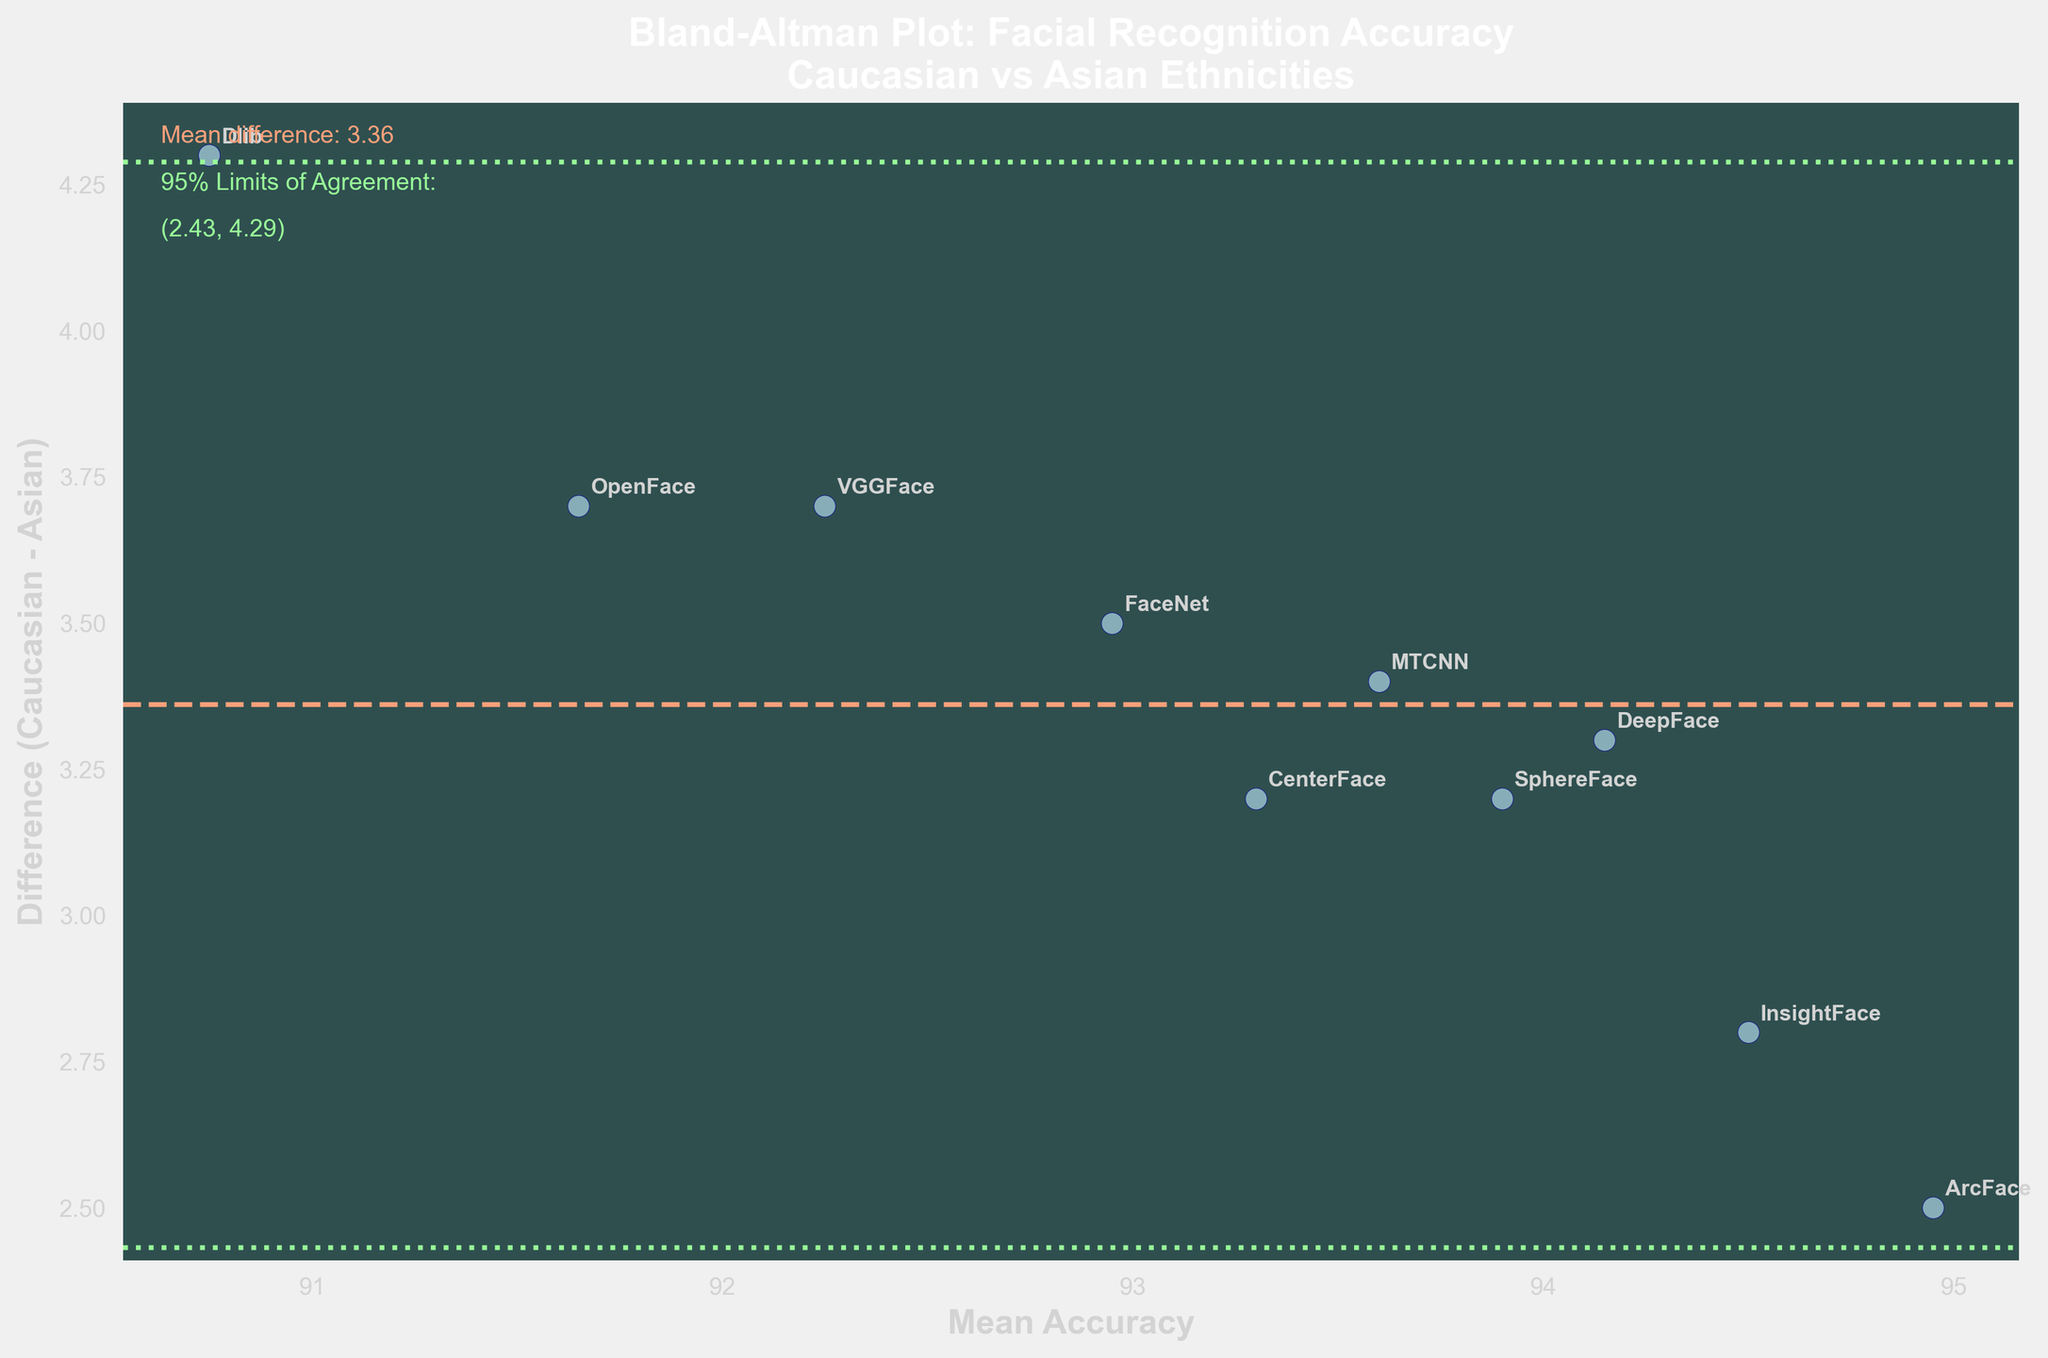what is the observed range for the difference in accuracy between Caucasian and Asian ethnicities? By examining the y-axis of the plot, the minimum and maximum values of the differences can be observed. The lowest difference is around 2.5%, and the highest is around 4.3%.
Answer: 2.5% to 4.3% How many facial recognition methods are compared in the plot? Count the number of unique data points or labels annotated on the plot. Each point represents a different method.
Answer: 10 What is the mean difference in accuracy between the two ethnicities? The mean difference is marked by a solid line on the plot, typically displayed above it in text.
Answer: 3.36% Are there any facial recognition methods with a higher mean accuracy for Caucasians compared to Asians? All points on the plot are above the zero line on the y-axis, indicating a positive difference and therefore, higher performance for Caucasians in all methods.
Answer: Yes What are the 95% limits of agreement for the accuracy differences? These limits can be determined by the dotted lines on the plot and the accompanying text annotation. The limits are given by the mean difference plus or minus 1.96 times the standard deviation of the differences.
Answer: (2.43%, 4.29%) Which facial recognition method has the smallest difference in accuracy between the two ethnicities? By examining the points on the plot, the method with the smallest y-value for the difference is identified. ArcFace, with a difference of 2.5%, has the smallest difference.
Answer: ArcFace Which facial recognition method has the largest discrepancy in accuracy between the two ethnicities, and what is the difference? Dlib has the largest difference of 4.3%, as evidenced by its position on the plot.
Answer: Dlib, 4.3% What is the mean accuracy of the facial recognition method with the smallest difference? Locate the point corresponding to the smallest difference (ArcFace) and read its x-value to find the mean accuracy.
Answer: 95% Which facial recognition methods have a mean accuracy above 95%? Observe the x-axis values and identify methods with mean accuracy above 95. DeepFace, ArcFace, and InsightFace all have mean accuracies above 95%.
Answer: DeepFace, ArcFace, InsightFace Is the mean difference line above the zero line? Look at the position of the solid mean difference line relative to the zero value on the y-axis. It is above the zero line, indicating higher accuracy for Caucasians overall.
Answer: Yes 